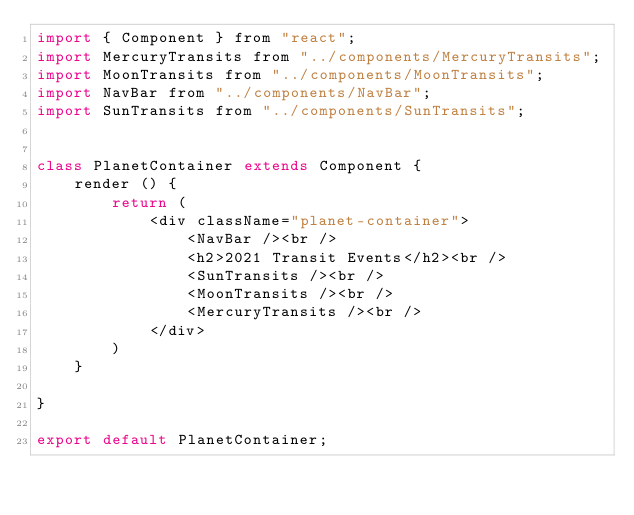<code> <loc_0><loc_0><loc_500><loc_500><_JavaScript_>import { Component } from "react";
import MercuryTransits from "../components/MercuryTransits";
import MoonTransits from "../components/MoonTransits";
import NavBar from "../components/NavBar";
import SunTransits from "../components/SunTransits";


class PlanetContainer extends Component {
    render () {
        return (
            <div className="planet-container">
                <NavBar /><br />
                <h2>2021 Transit Events</h2><br />
                <SunTransits /><br />
                <MoonTransits /><br />
                <MercuryTransits /><br />
            </div>
        )
    }

}

export default PlanetContainer;</code> 